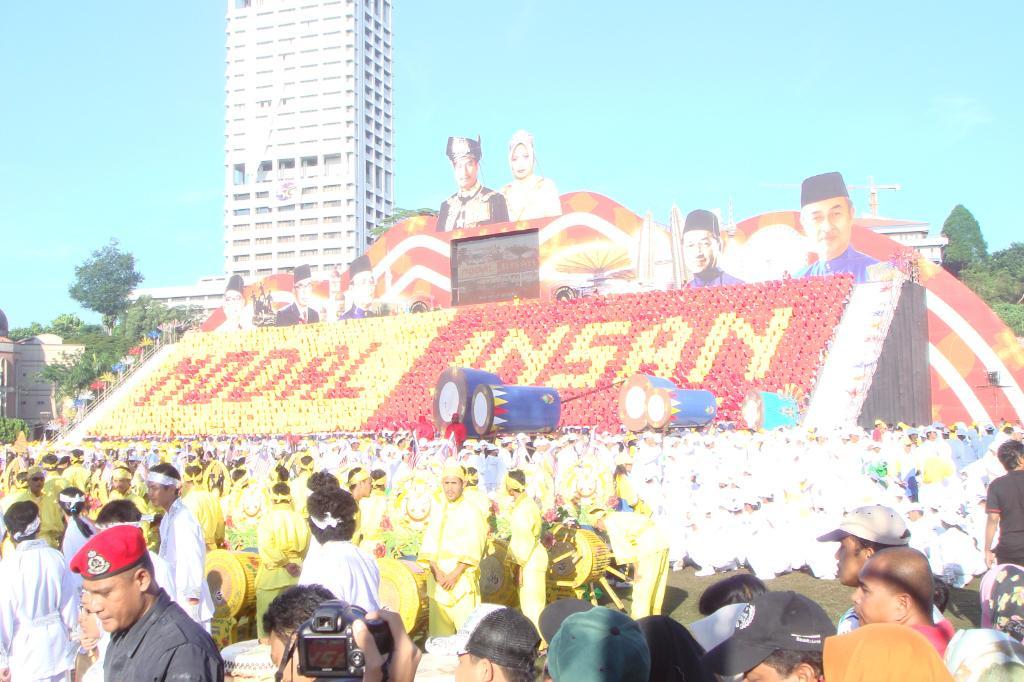Describe this image in one or two sentences. In the background we can see the sky, buildings, tower crane, trees. In this picture we can see some objects, boards. At the bottom portion of the picture we can see the people. We can see a person hand holding a camera. On the left side of the picture we can see some colorful objects. 